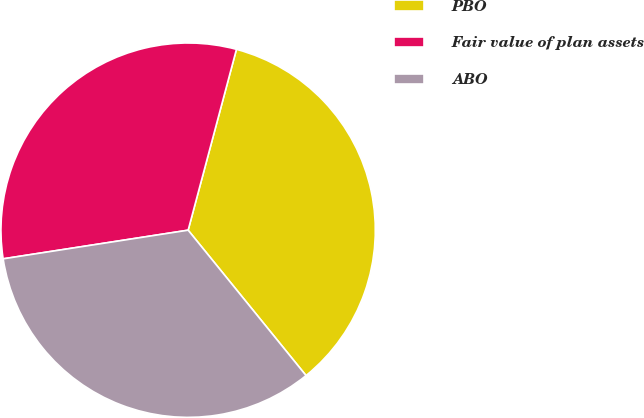Convert chart. <chart><loc_0><loc_0><loc_500><loc_500><pie_chart><fcel>PBO<fcel>Fair value of plan assets<fcel>ABO<nl><fcel>35.0%<fcel>31.6%<fcel>33.4%<nl></chart> 